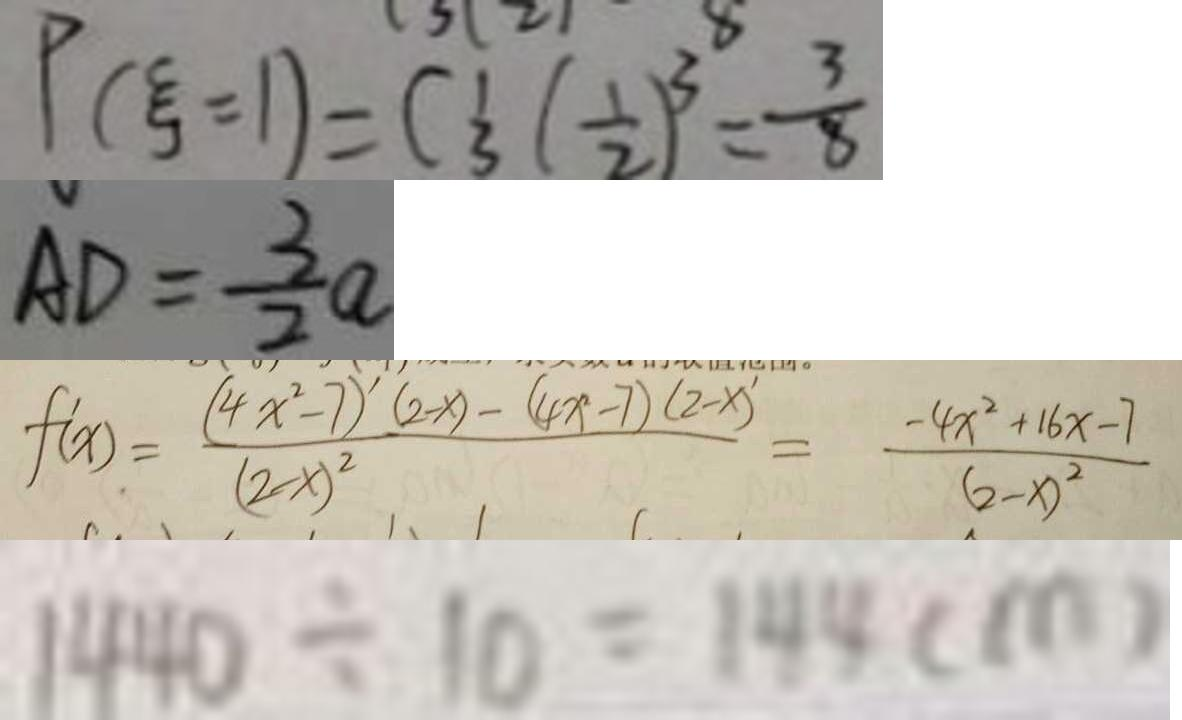<formula> <loc_0><loc_0><loc_500><loc_500>P ( \varepsilon = 1 ) = C _ { 3 } ^ { 1 } ( \frac { 1 } { 2 } ) ^ { 3 } = \frac { 3 } { 8 } 
 A D = \frac { 3 } { 2 } a 
 f ^ { \prime } ( x ) = \frac { ( 4 x ^ { 2 } - 7 ) ^ { \prime } ( 2 - x ) - ( 4 x - 7 ) ( 2 - x ) ^ { \prime } } { ( 2 - x ) ^ { 2 } } = \frac { - 4 x ^ { 2 } + 1 6 x - 7 } { ( 2 - x ) ^ { 2 } } 
 1 4 4 0 \div 1 0 = 1 4 4 ( m )</formula> 